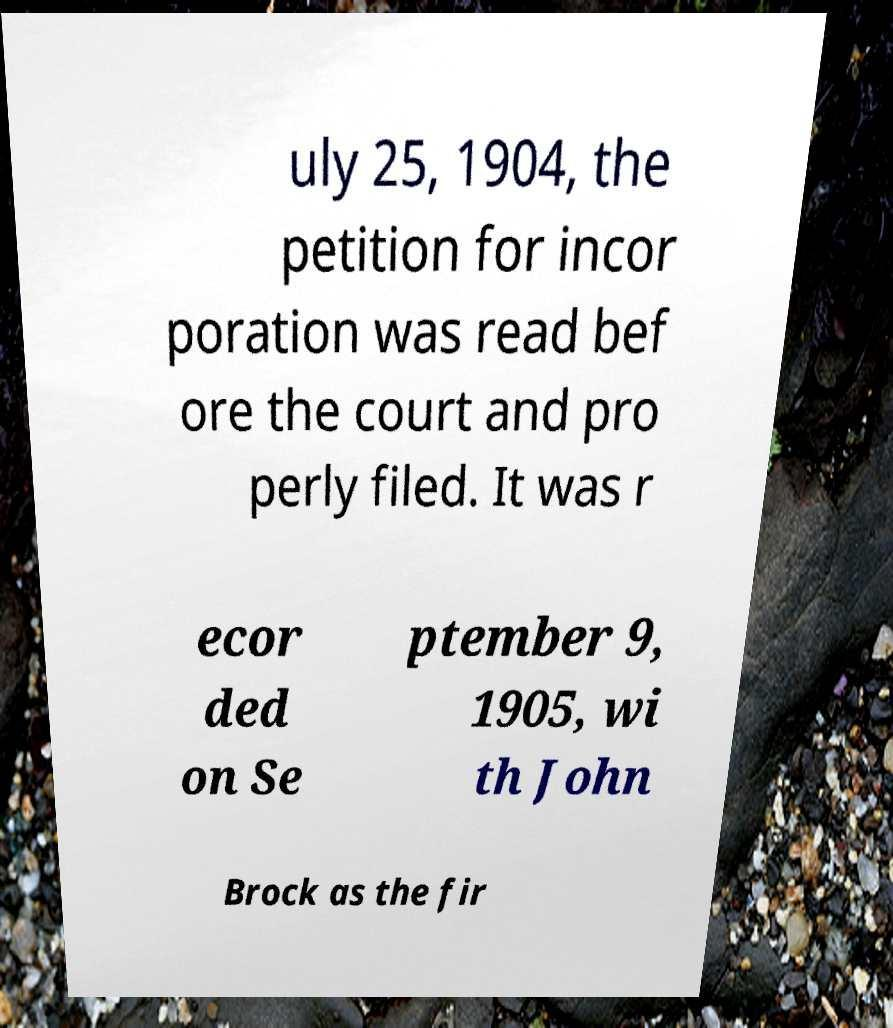Could you extract and type out the text from this image? uly 25, 1904, the petition for incor poration was read bef ore the court and pro perly filed. It was r ecor ded on Se ptember 9, 1905, wi th John Brock as the fir 